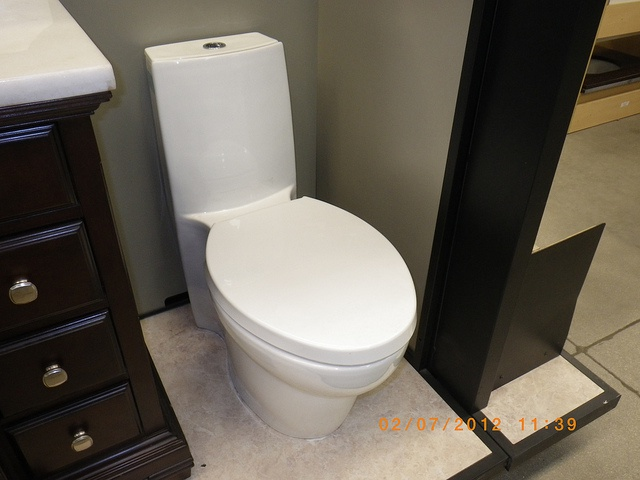Describe the objects in this image and their specific colors. I can see a toilet in lightgray, darkgray, and gray tones in this image. 